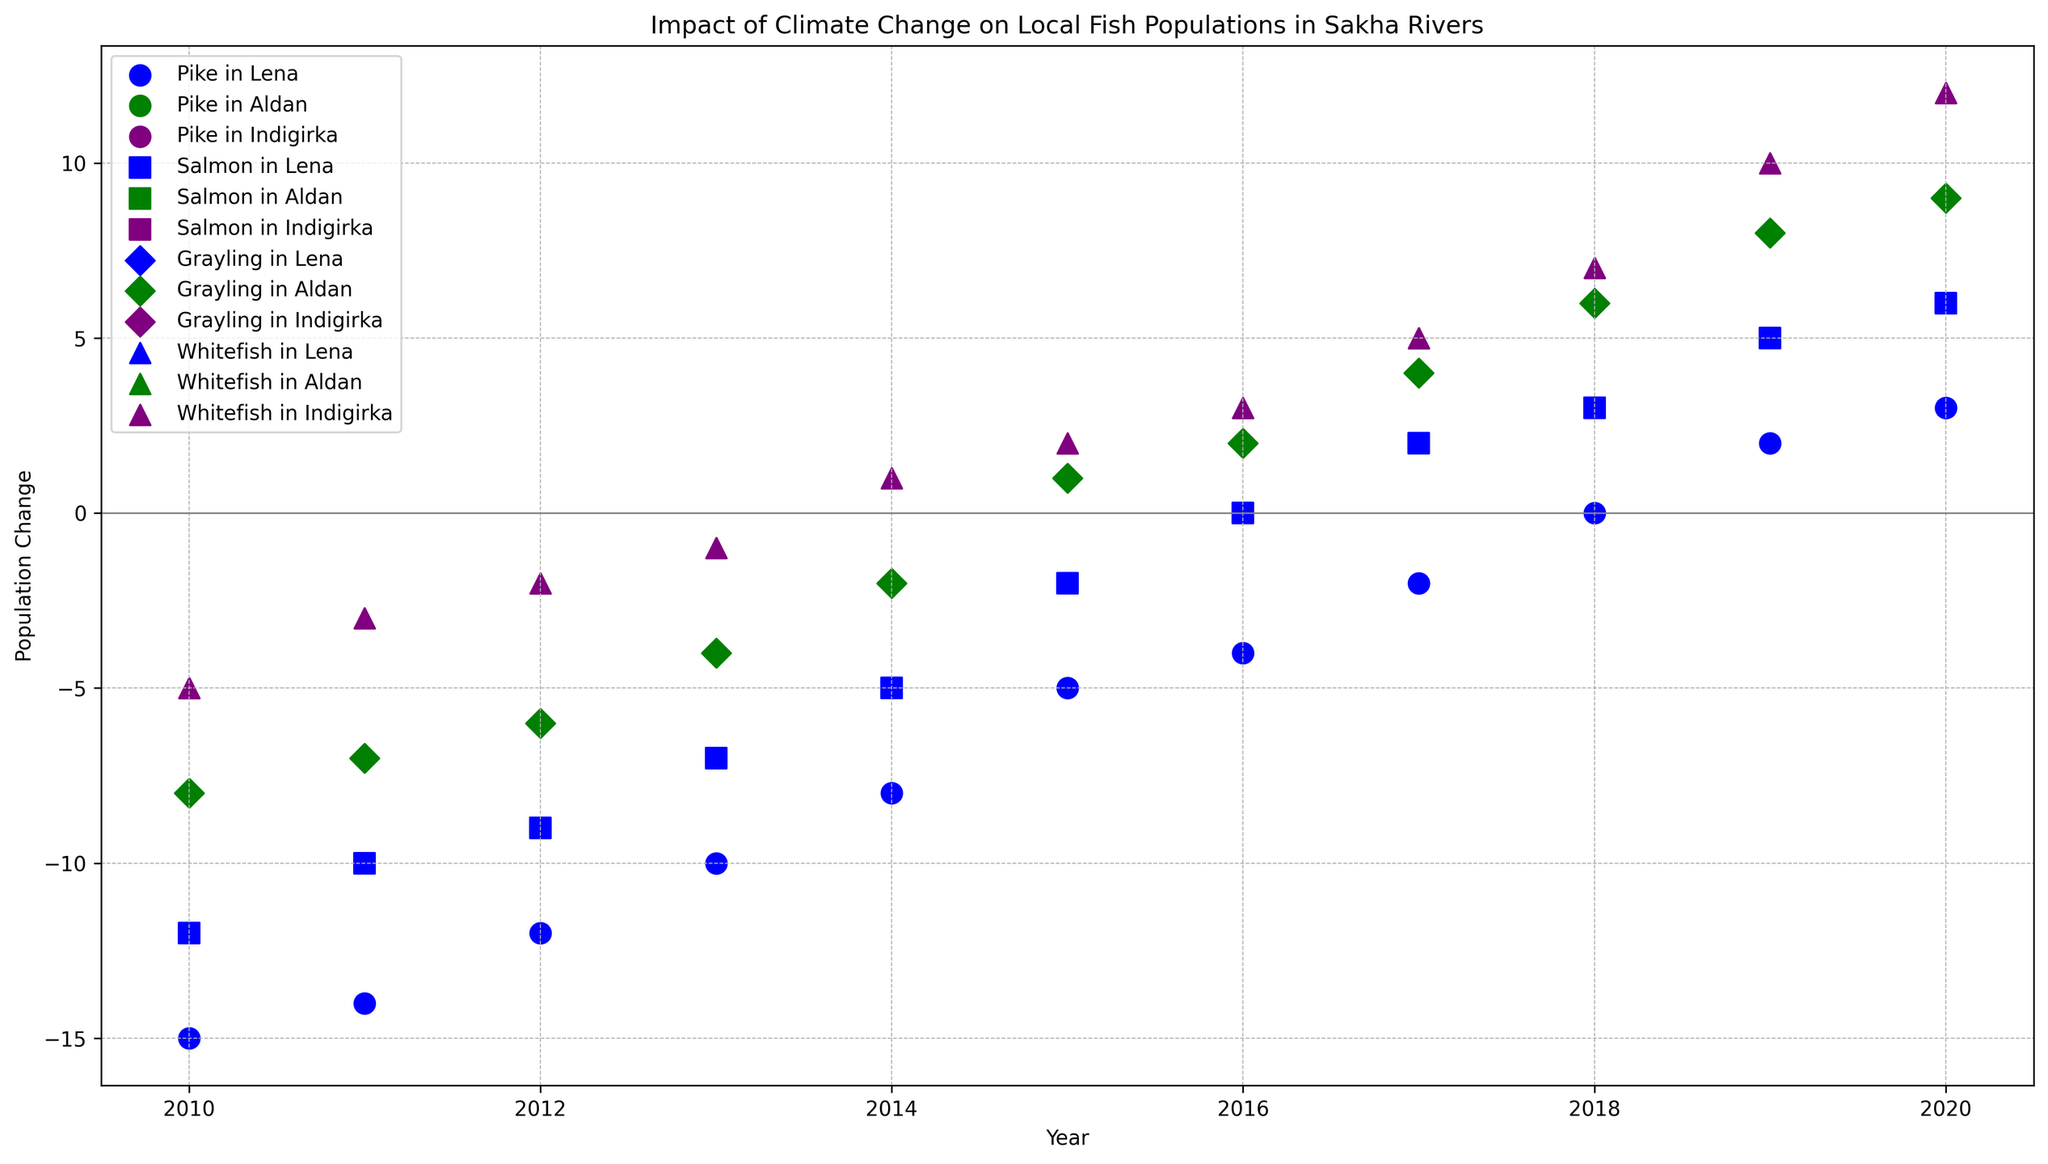When did the Pike population in the Lena river first show a positive change? The data points scattered across each year for Pike in the Lena river should be examined. The positive change is first seen in 2019.
Answer: 2019 How does the population change of Grayling in the Aldan river compare to the change in Whitefish in the Indigirka river in the year 2015? For 2015, we refer to the scatter markers for Grayling in the Aldan river and Whitefish in the Indigirka river. For Grayling, the population change is +1, whereas for Whitefish, it is +2. Thus, Whitefish showed a greater increase by 1.
Answer: Whitefish had a greater increase than Grayling by 1 By how much did the Salmon population change in the Lena river from 2017 to 2018? Look at the Salmon population change for the Lena river in both 2017 and 2018. It increased from +2 in 2017 to +3 in 2018. The change calculated is 3 - 2 = 1.
Answer: Increased by 1 Which river had the most significant increase in fish population in 2020? We observe the population changes across all fish species in the year 2020 and note the river with the highest point. Whitefish in the Indigirka river with a change of +12 is the most significant.
Answer: Indigirka Do any fish species in any river show a population decrease every year from 2010 to 2020? We check each fish species and each river for continuous negative values across all years. Pike and Salmon in the Lena river showed a decrease every year up to 2014, after which their values turned positive. Thus, no species shows a continuous decrease throughout the entire period.
Answer: No What trend do we observe for the Grayling population in the Aldan river from 2015 to 2020? Examine the data points for Grayling in the Aldan river. The change values are: 2015 (+1), 2016 (+2), 2017 (+4), 2018 (+6), 2019 (+8), 2020 (+9). The trend shows a steady increase.
Answer: Steady increase Which species in the Lena river shows the earliest instance of a positive population change? Analyze the data points for each species in the Lena river. Pike shows a positive change in 2019 and Salmon in 2017. Therefore, Salmon exhibits the earliest positive change in 2017.
Answer: Salmon By how much did the population change of Whitefish in the Indigirka river from 2010 to 2020? Look at the Whitefish population change for the Indigirka river in 2010 and 2020. The change values are -5 in 2010 and +12 in 2020. The difference between the two values is 12 - (-5) = 17.
Answer: Increased by 17 